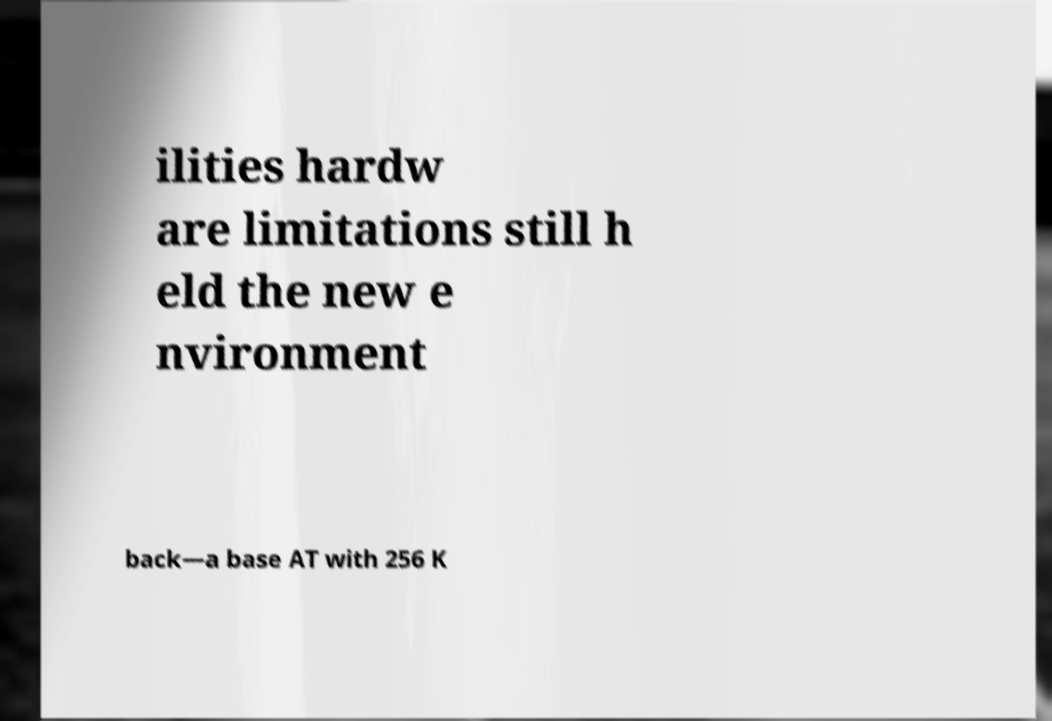Could you assist in decoding the text presented in this image and type it out clearly? ilities hardw are limitations still h eld the new e nvironment back—a base AT with 256 K 